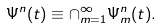Convert formula to latex. <formula><loc_0><loc_0><loc_500><loc_500>\Psi ^ { n } ( t ) \equiv \cap _ { m = 1 } ^ { \infty } \Psi _ { m } ^ { n } ( t ) .</formula> 